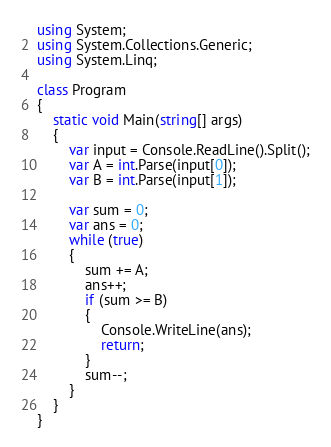Convert code to text. <code><loc_0><loc_0><loc_500><loc_500><_C#_>using System;
using System.Collections.Generic;
using System.Linq;

class Program
{
    static void Main(string[] args)
    {
        var input = Console.ReadLine().Split();
        var A = int.Parse(input[0]);    
        var B = int.Parse(input[1]);

        var sum = 0;
        var ans = 0;
        while (true)
        {
            sum += A;
            ans++;
            if (sum >= B)
            {
                Console.WriteLine(ans);
                return;
            }
            sum--;
        }
    }
}
</code> 